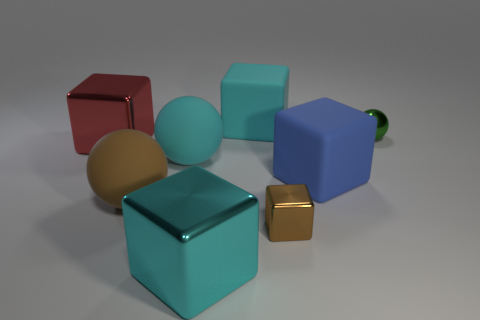How would you describe the lighting and shadows in the image? The lighting in the image appears to be diffused, possibly from a single source given the direction of the shadows. The shadows are soft-edged and extend to the right, which helps create a sense of depth and dimension in the scene. 